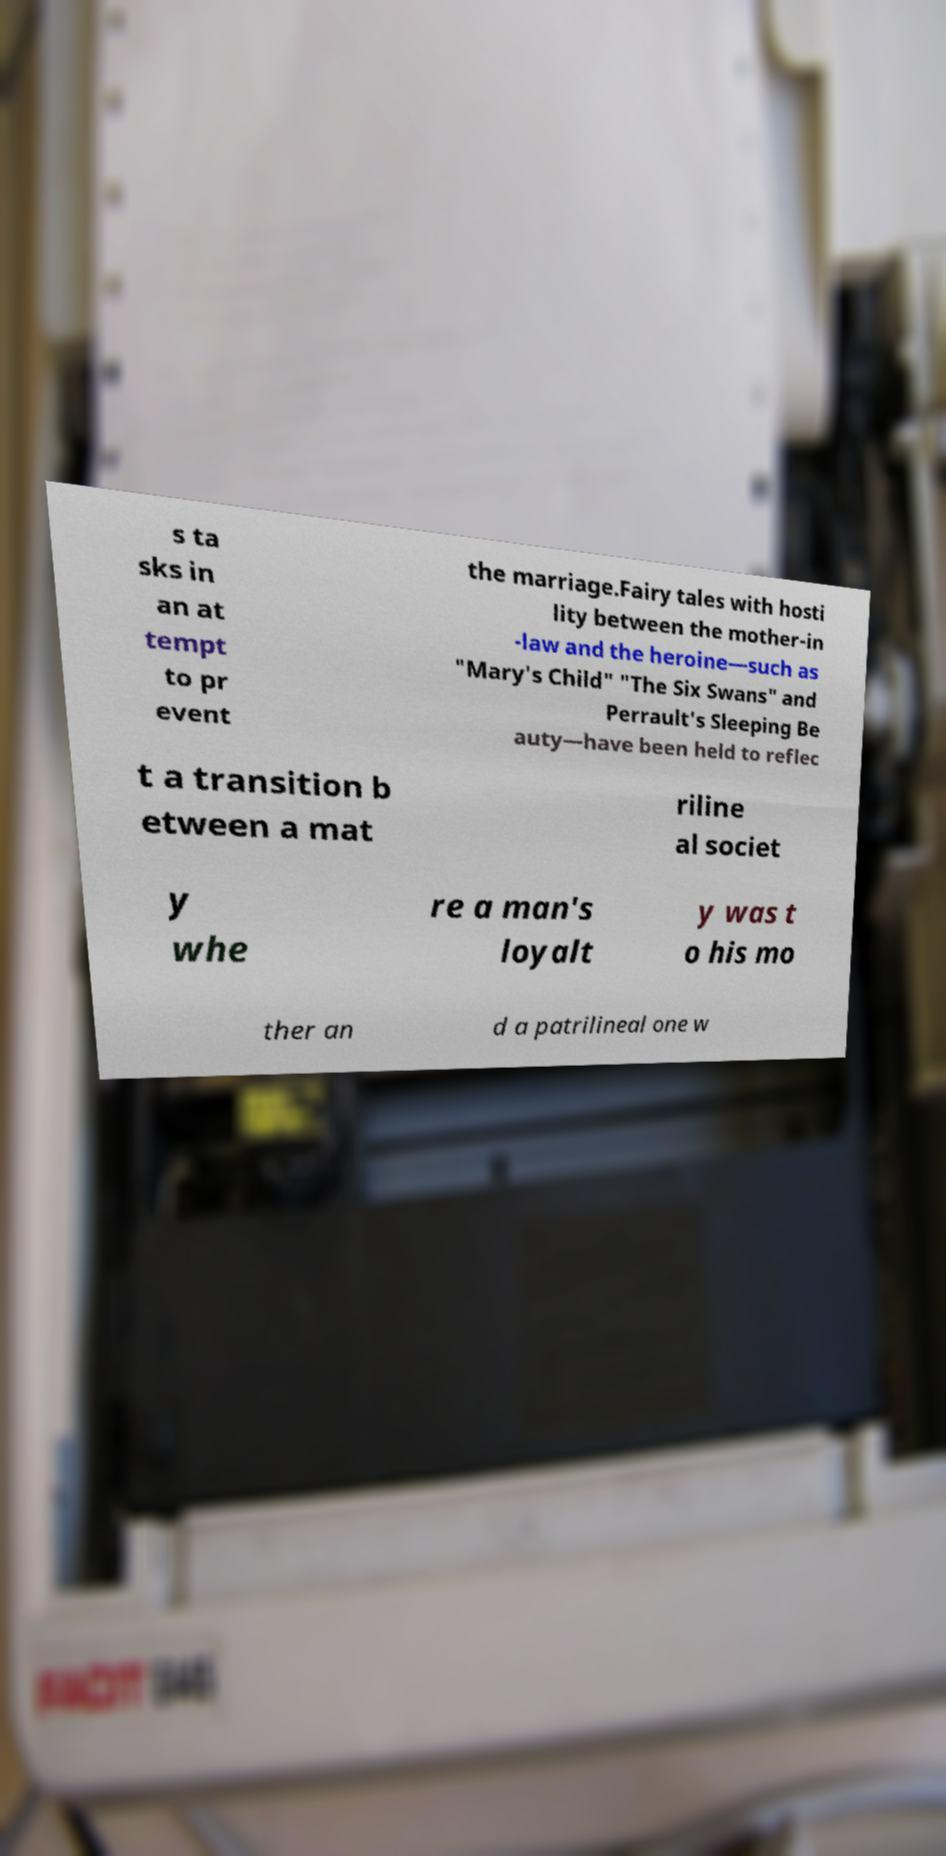There's text embedded in this image that I need extracted. Can you transcribe it verbatim? s ta sks in an at tempt to pr event the marriage.Fairy tales with hosti lity between the mother-in -law and the heroine—such as "Mary's Child" "The Six Swans" and Perrault's Sleeping Be auty—have been held to reflec t a transition b etween a mat riline al societ y whe re a man's loyalt y was t o his mo ther an d a patrilineal one w 